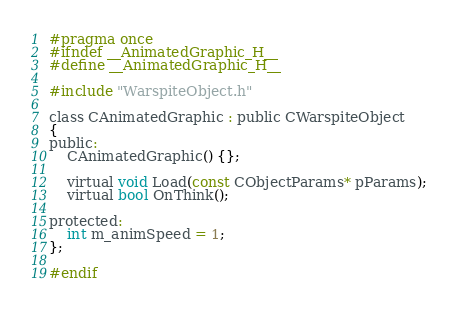Convert code to text. <code><loc_0><loc_0><loc_500><loc_500><_C_>#pragma once
#ifndef __AnimatedGraphic_H__
#define __AnimatedGraphic_H__

#include "WarspiteObject.h"

class CAnimatedGraphic : public CWarspiteObject
{
public:
	CAnimatedGraphic() {};

	virtual void Load(const CObjectParams* pParams);
	virtual bool OnThink();

protected:
	int m_animSpeed = 1;
};

#endif</code> 